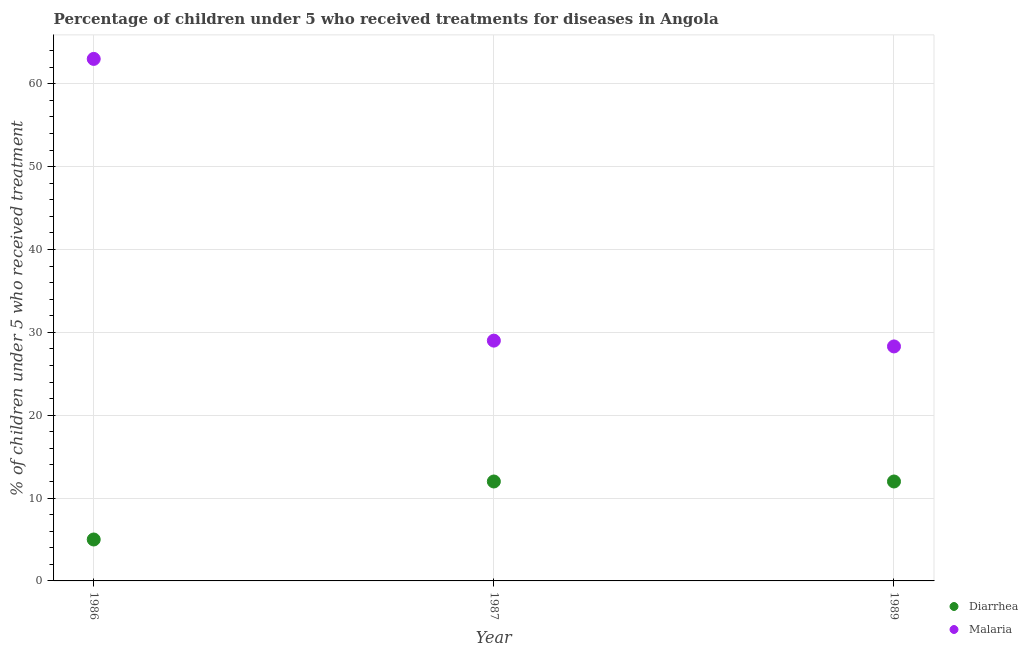Is the number of dotlines equal to the number of legend labels?
Offer a terse response. Yes. What is the percentage of children who received treatment for diarrhoea in 1989?
Your answer should be very brief. 12. Across all years, what is the maximum percentage of children who received treatment for diarrhoea?
Your response must be concise. 12. Across all years, what is the minimum percentage of children who received treatment for diarrhoea?
Make the answer very short. 5. What is the total percentage of children who received treatment for diarrhoea in the graph?
Offer a terse response. 29. What is the difference between the percentage of children who received treatment for diarrhoea in 1987 and that in 1989?
Offer a terse response. 0. What is the difference between the percentage of children who received treatment for malaria in 1989 and the percentage of children who received treatment for diarrhoea in 1987?
Keep it short and to the point. 16.3. What is the average percentage of children who received treatment for malaria per year?
Your response must be concise. 40.1. What is the ratio of the percentage of children who received treatment for malaria in 1986 to that in 1989?
Your answer should be compact. 2.23. Is the percentage of children who received treatment for diarrhoea in 1986 less than that in 1987?
Ensure brevity in your answer.  Yes. Is the difference between the percentage of children who received treatment for malaria in 1986 and 1989 greater than the difference between the percentage of children who received treatment for diarrhoea in 1986 and 1989?
Ensure brevity in your answer.  Yes. What is the difference between the highest and the second highest percentage of children who received treatment for malaria?
Provide a short and direct response. 34. What is the difference between the highest and the lowest percentage of children who received treatment for diarrhoea?
Keep it short and to the point. 7. In how many years, is the percentage of children who received treatment for diarrhoea greater than the average percentage of children who received treatment for diarrhoea taken over all years?
Your answer should be very brief. 2. Is the percentage of children who received treatment for malaria strictly greater than the percentage of children who received treatment for diarrhoea over the years?
Give a very brief answer. Yes. Is the percentage of children who received treatment for malaria strictly less than the percentage of children who received treatment for diarrhoea over the years?
Offer a very short reply. No. How many dotlines are there?
Your answer should be very brief. 2. What is the difference between two consecutive major ticks on the Y-axis?
Give a very brief answer. 10. How many legend labels are there?
Provide a succinct answer. 2. How are the legend labels stacked?
Keep it short and to the point. Vertical. What is the title of the graph?
Ensure brevity in your answer.  Percentage of children under 5 who received treatments for diseases in Angola. Does "Fraud firms" appear as one of the legend labels in the graph?
Make the answer very short. No. What is the label or title of the X-axis?
Offer a terse response. Year. What is the label or title of the Y-axis?
Your response must be concise. % of children under 5 who received treatment. What is the % of children under 5 who received treatment in Malaria in 1986?
Your answer should be compact. 63. What is the % of children under 5 who received treatment in Diarrhea in 1987?
Offer a terse response. 12. What is the % of children under 5 who received treatment in Malaria in 1987?
Your answer should be very brief. 29. What is the % of children under 5 who received treatment in Malaria in 1989?
Ensure brevity in your answer.  28.3. Across all years, what is the maximum % of children under 5 who received treatment of Malaria?
Give a very brief answer. 63. Across all years, what is the minimum % of children under 5 who received treatment of Malaria?
Your answer should be very brief. 28.3. What is the total % of children under 5 who received treatment in Diarrhea in the graph?
Ensure brevity in your answer.  29. What is the total % of children under 5 who received treatment of Malaria in the graph?
Your answer should be compact. 120.3. What is the difference between the % of children under 5 who received treatment of Diarrhea in 1986 and that in 1987?
Offer a very short reply. -7. What is the difference between the % of children under 5 who received treatment in Diarrhea in 1986 and that in 1989?
Keep it short and to the point. -7. What is the difference between the % of children under 5 who received treatment of Malaria in 1986 and that in 1989?
Make the answer very short. 34.7. What is the difference between the % of children under 5 who received treatment in Malaria in 1987 and that in 1989?
Provide a short and direct response. 0.7. What is the difference between the % of children under 5 who received treatment in Diarrhea in 1986 and the % of children under 5 who received treatment in Malaria in 1987?
Make the answer very short. -24. What is the difference between the % of children under 5 who received treatment in Diarrhea in 1986 and the % of children under 5 who received treatment in Malaria in 1989?
Your response must be concise. -23.3. What is the difference between the % of children under 5 who received treatment in Diarrhea in 1987 and the % of children under 5 who received treatment in Malaria in 1989?
Give a very brief answer. -16.3. What is the average % of children under 5 who received treatment of Diarrhea per year?
Provide a succinct answer. 9.67. What is the average % of children under 5 who received treatment in Malaria per year?
Provide a succinct answer. 40.1. In the year 1986, what is the difference between the % of children under 5 who received treatment in Diarrhea and % of children under 5 who received treatment in Malaria?
Ensure brevity in your answer.  -58. In the year 1989, what is the difference between the % of children under 5 who received treatment of Diarrhea and % of children under 5 who received treatment of Malaria?
Give a very brief answer. -16.3. What is the ratio of the % of children under 5 who received treatment in Diarrhea in 1986 to that in 1987?
Your response must be concise. 0.42. What is the ratio of the % of children under 5 who received treatment in Malaria in 1986 to that in 1987?
Your response must be concise. 2.17. What is the ratio of the % of children under 5 who received treatment of Diarrhea in 1986 to that in 1989?
Your response must be concise. 0.42. What is the ratio of the % of children under 5 who received treatment in Malaria in 1986 to that in 1989?
Your answer should be compact. 2.23. What is the ratio of the % of children under 5 who received treatment of Diarrhea in 1987 to that in 1989?
Keep it short and to the point. 1. What is the ratio of the % of children under 5 who received treatment of Malaria in 1987 to that in 1989?
Give a very brief answer. 1.02. What is the difference between the highest and the lowest % of children under 5 who received treatment of Malaria?
Your answer should be very brief. 34.7. 